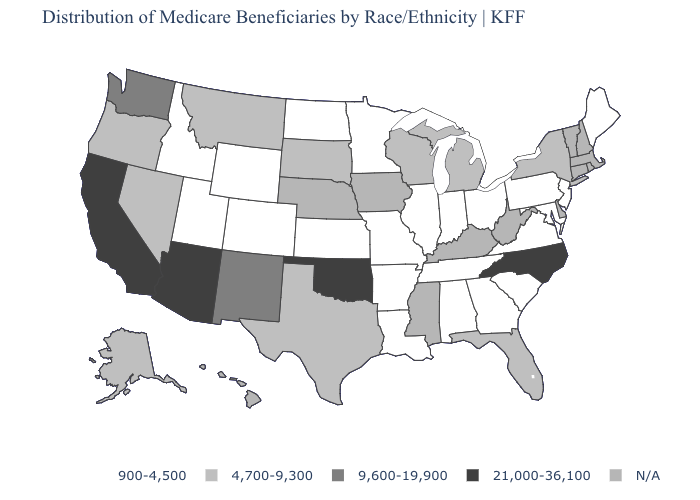What is the value of Iowa?
Concise answer only. N/A. Name the states that have a value in the range 21,000-36,100?
Quick response, please. Arizona, California, North Carolina, Oklahoma. What is the value of Missouri?
Short answer required. 900-4,500. Which states hav the highest value in the Northeast?
Give a very brief answer. New York. Which states have the lowest value in the Northeast?
Concise answer only. Maine, New Jersey, Pennsylvania. Name the states that have a value in the range N/A?
Answer briefly. Connecticut, Delaware, Hawaii, Iowa, Kentucky, Massachusetts, Mississippi, Nebraska, New Hampshire, Rhode Island, Vermont, West Virginia. What is the value of Virginia?
Keep it brief. 900-4,500. Among the states that border Louisiana , which have the lowest value?
Write a very short answer. Arkansas. Name the states that have a value in the range N/A?
Quick response, please. Connecticut, Delaware, Hawaii, Iowa, Kentucky, Massachusetts, Mississippi, Nebraska, New Hampshire, Rhode Island, Vermont, West Virginia. Which states hav the highest value in the South?
Keep it brief. North Carolina, Oklahoma. Does Florida have the lowest value in the South?
Answer briefly. No. Name the states that have a value in the range 9,600-19,900?
Keep it brief. New Mexico, Washington. Does Kansas have the highest value in the MidWest?
Answer briefly. No. What is the lowest value in the Northeast?
Write a very short answer. 900-4,500. What is the highest value in the USA?
Answer briefly. 21,000-36,100. 